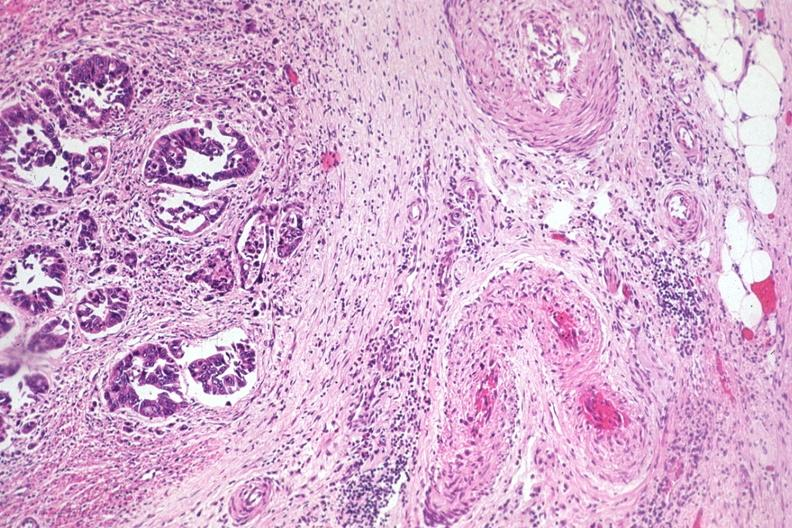does thyroid show typical infiltrating adenocarcinoma extending to serosal fat?
Answer the question using a single word or phrase. No 